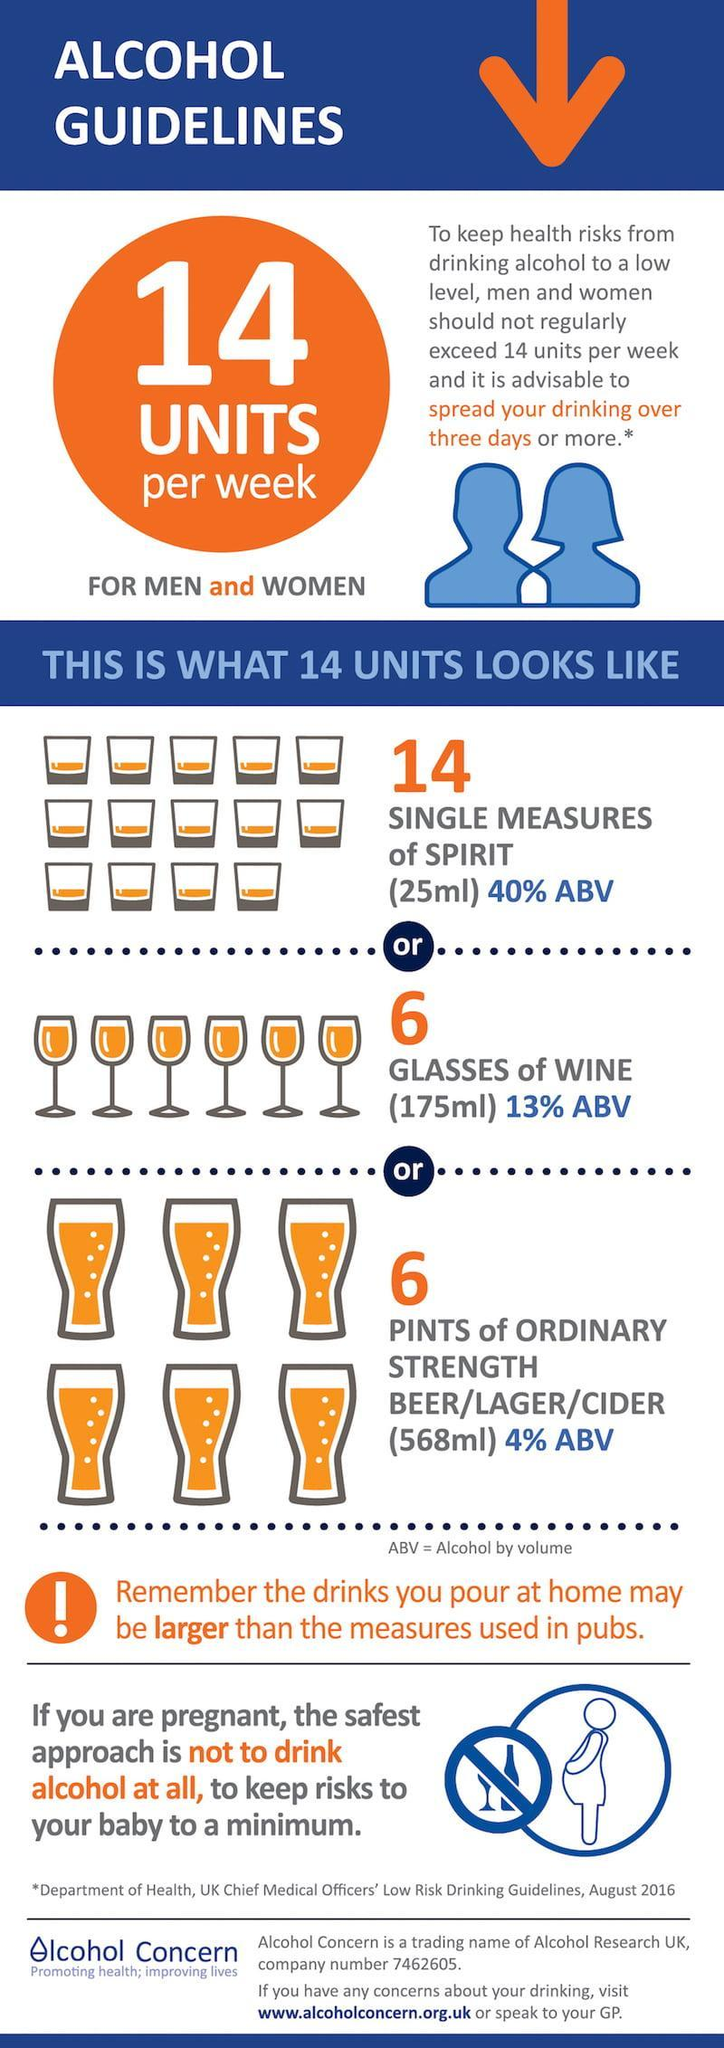What is the color of number six -blue, orange, or white?
Answer the question with a short phrase. orange What is the number of pregnant ladies icons in this infographic? 1 How many types of glasses are in this infographic? 3 